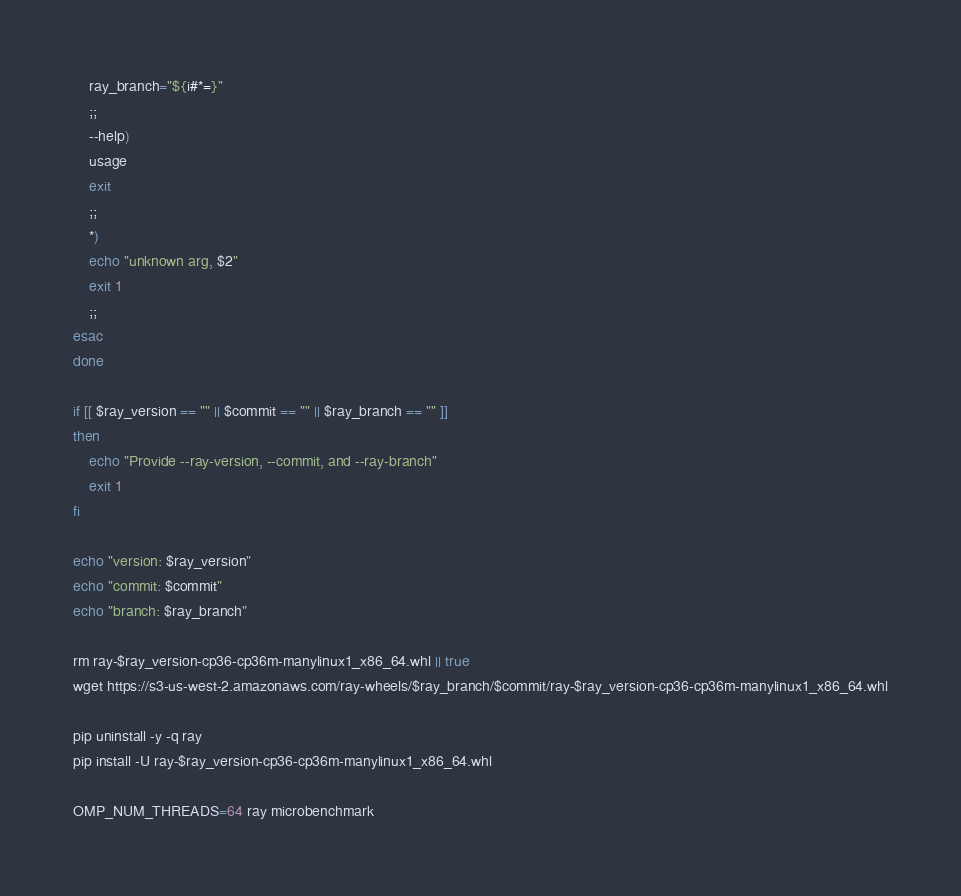<code> <loc_0><loc_0><loc_500><loc_500><_Bash_>    ray_branch="${i#*=}"
    ;;
    --help)
    usage
    exit
    ;;
    *)
    echo "unknown arg, $2"
    exit 1
    ;;
esac
done

if [[ $ray_version == "" || $commit == "" || $ray_branch == "" ]]
then
    echo "Provide --ray-version, --commit, and --ray-branch"
    exit 1
fi

echo "version: $ray_version"
echo "commit: $commit"
echo "branch: $ray_branch"

rm ray-$ray_version-cp36-cp36m-manylinux1_x86_64.whl || true
wget https://s3-us-west-2.amazonaws.com/ray-wheels/$ray_branch/$commit/ray-$ray_version-cp36-cp36m-manylinux1_x86_64.whl
      
pip uninstall -y -q ray
pip install -U ray-$ray_version-cp36-cp36m-manylinux1_x86_64.whl

OMP_NUM_THREADS=64 ray microbenchmark
</code> 